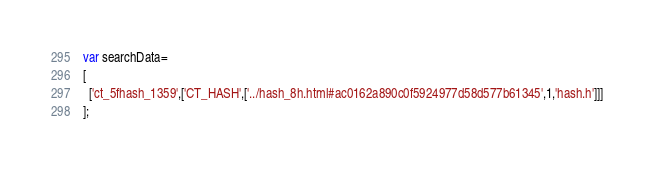Convert code to text. <code><loc_0><loc_0><loc_500><loc_500><_JavaScript_>var searchData=
[
  ['ct_5fhash_1359',['CT_HASH',['../hash_8h.html#ac0162a890c0f5924977d58d577b61345',1,'hash.h']]]
];
</code> 